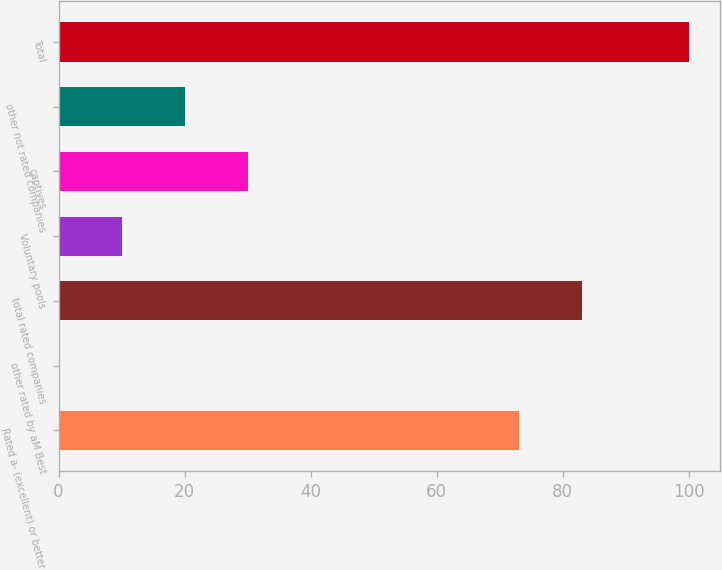Convert chart to OTSL. <chart><loc_0><loc_0><loc_500><loc_500><bar_chart><fcel>Rated a- (excellent) or better<fcel>other rated by aM Best<fcel>total rated companies<fcel>Voluntary pools<fcel>captives<fcel>other not rated companies<fcel>Total<nl><fcel>73.1<fcel>0.1<fcel>83.09<fcel>10.09<fcel>30.07<fcel>20.08<fcel>100<nl></chart> 